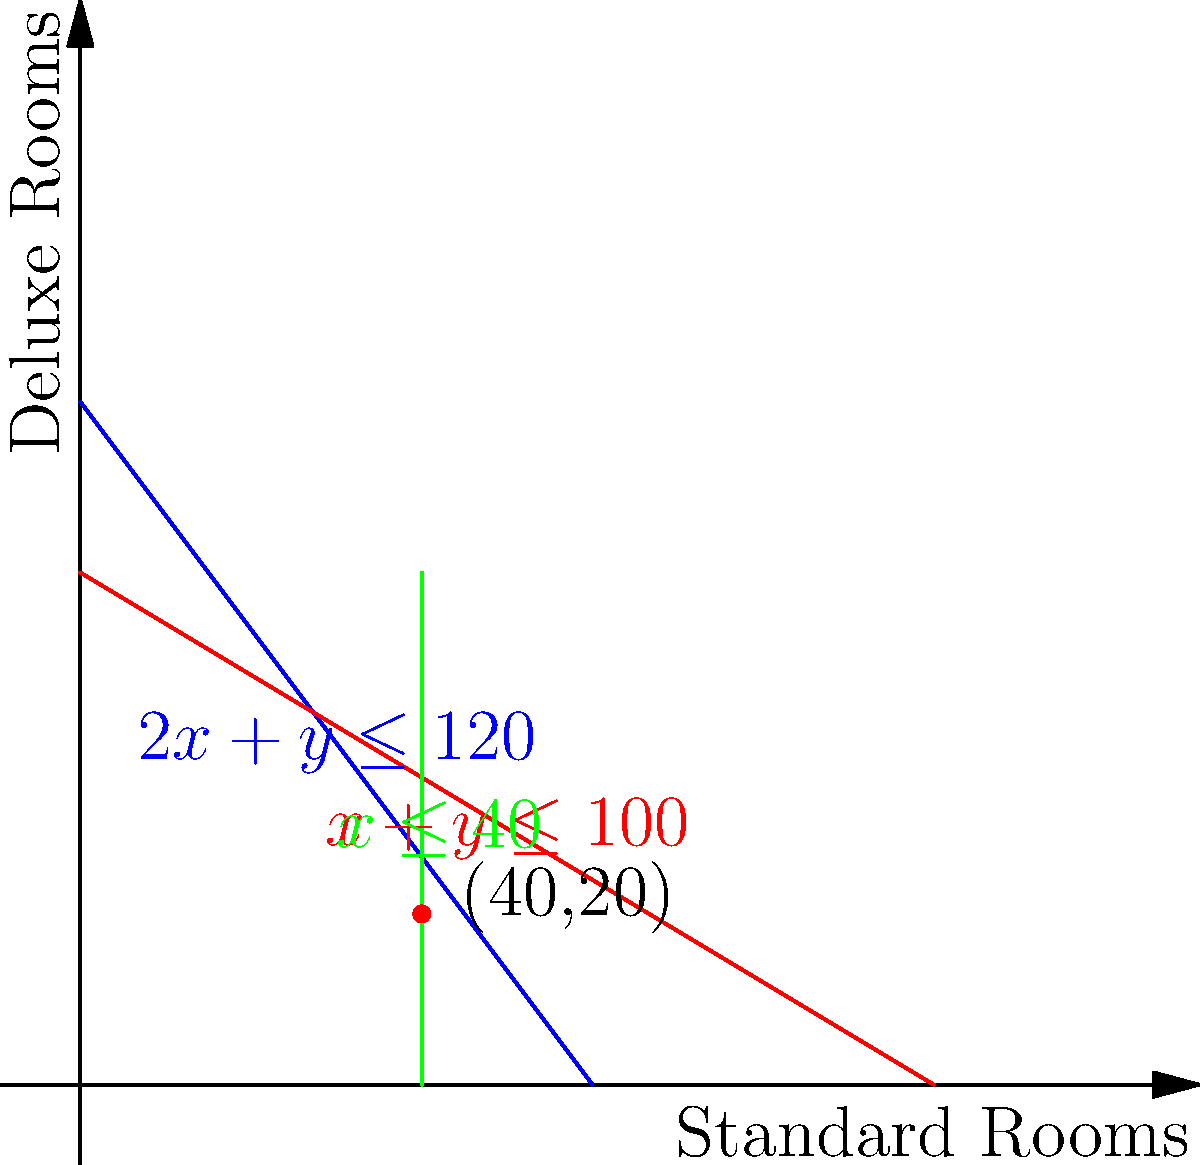A guesthouse has standard and deluxe rooms. The total number of rooms cannot exceed 100, and there are at most 40 standard rooms available. Each standard room requires 2 hours of cleaning, while each deluxe room requires 1 hour, with a total of 120 cleaning hours available per day. If the profit for a standard room is $80 and for a deluxe room is $100, how many of each type should be booked to maximize daily profit? To solve this linear programming problem, we need to follow these steps:

1. Identify the constraints:
   a. Total rooms: $x + y \leq 100$ (red line)
   b. Standard rooms: $x \leq 40$ (green line)
   c. Cleaning hours: $2x + y \leq 120$ (blue line)
   Where $x$ = number of standard rooms, $y$ = number of deluxe rooms

2. Write the objective function:
   Profit = $80x + 100y$

3. Plot the constraints on the graph and identify the feasible region.

4. Find the vertices of the feasible region:
   (0,0), (0,60), (40,20), (40,0)

5. Evaluate the objective function at each vertex:
   (0,0): $80(0) + 100(0) = 0$
   (0,60): $80(0) + 100(60) = 6000$
   (40,20): $80(40) + 100(20) = 5200$
   (40,0): $80(40) + 100(0) = 3200$

6. The maximum profit occurs at the point (0,60), but this doesn't use any standard rooms.
   The next best option is (40,20), which uses both room types and gives a higher profit than (40,0).

Therefore, to maximize profit while using both room types, the guesthouse should book 40 standard rooms and 20 deluxe rooms.
Answer: 40 standard rooms, 20 deluxe rooms 